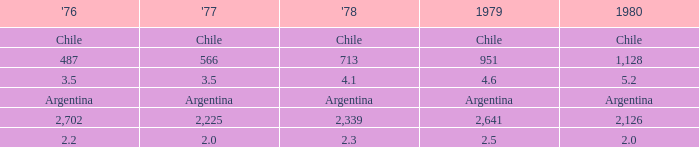What is 1977 when 1980 is chile? Chile. Could you parse the entire table? {'header': ["'76", "'77", "'78", '1979', '1980'], 'rows': [['Chile', 'Chile', 'Chile', 'Chile', 'Chile'], ['487', '566', '713', '951', '1,128'], ['3.5', '3.5', '4.1', '4.6', '5.2'], ['Argentina', 'Argentina', 'Argentina', 'Argentina', 'Argentina'], ['2,702', '2,225', '2,339', '2,641', '2,126'], ['2.2', '2.0', '2.3', '2.5', '2.0']]} 